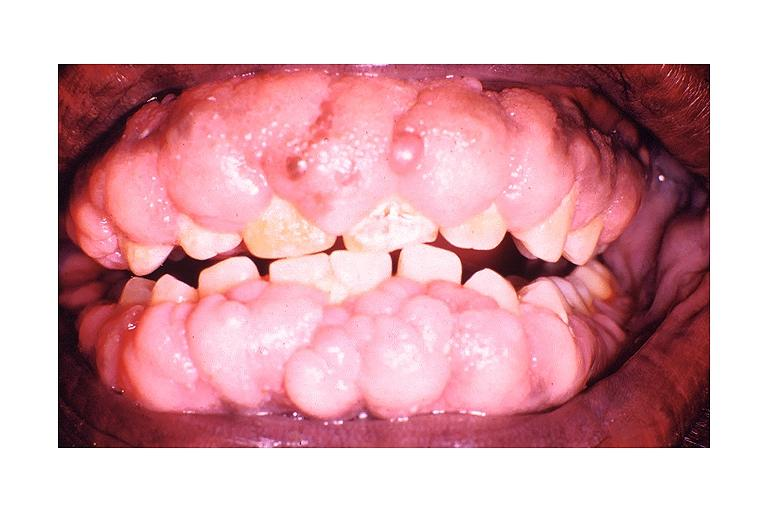what is dilantin induced?
Answer the question using a single word or phrase. Gingival hyperplasia 